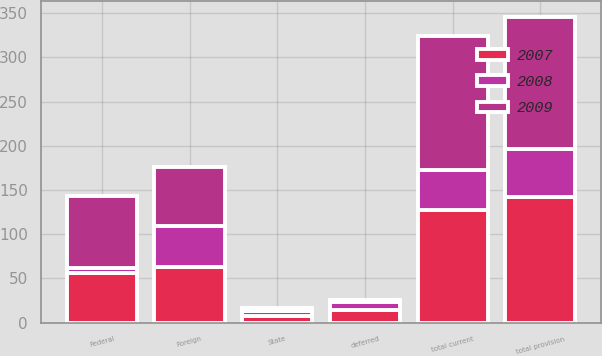Convert chart. <chart><loc_0><loc_0><loc_500><loc_500><stacked_bar_chart><ecel><fcel>Federal<fcel>State<fcel>Foreign<fcel>total current<fcel>deferred<fcel>total provision<nl><fcel>2007<fcel>56.4<fcel>8.1<fcel>63.3<fcel>127.8<fcel>14.9<fcel>142.7<nl><fcel>2008<fcel>6<fcel>4.7<fcel>46.2<fcel>44.9<fcel>8.7<fcel>53.6<nl><fcel>2009<fcel>81.3<fcel>4<fcel>66.7<fcel>152<fcel>2.3<fcel>149.7<nl></chart> 